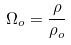<formula> <loc_0><loc_0><loc_500><loc_500>\Omega _ { o } = \frac { \rho } { \rho _ { o } }</formula> 